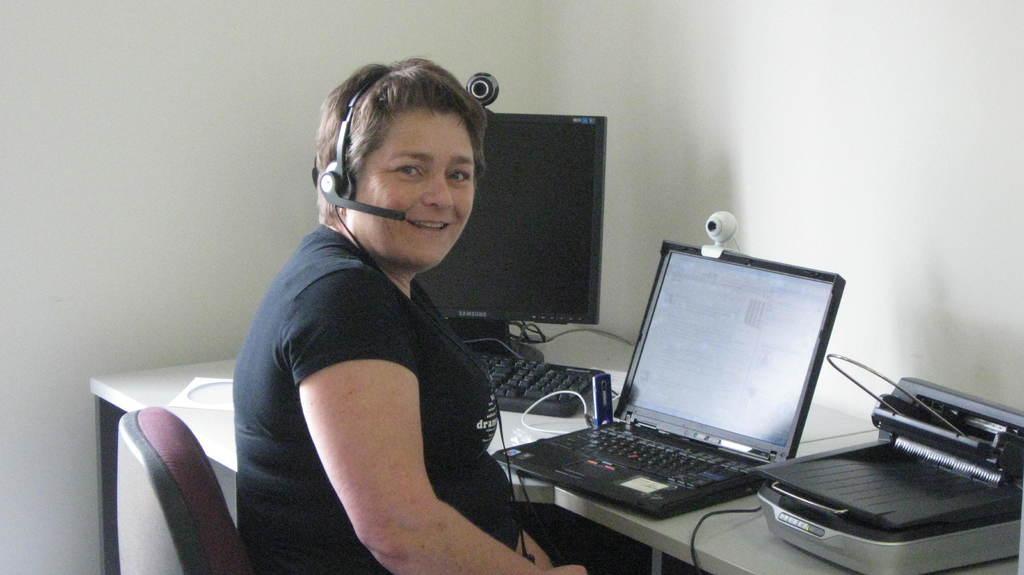Could you give a brief overview of what you see in this image? In this image there is a woman sitting in a chair is wearing a head phone is having a smile on her face, in front of the woman on the table there is a laptop, monitor, keyboard, cables and some other objects, in front of the table there is a wall. 